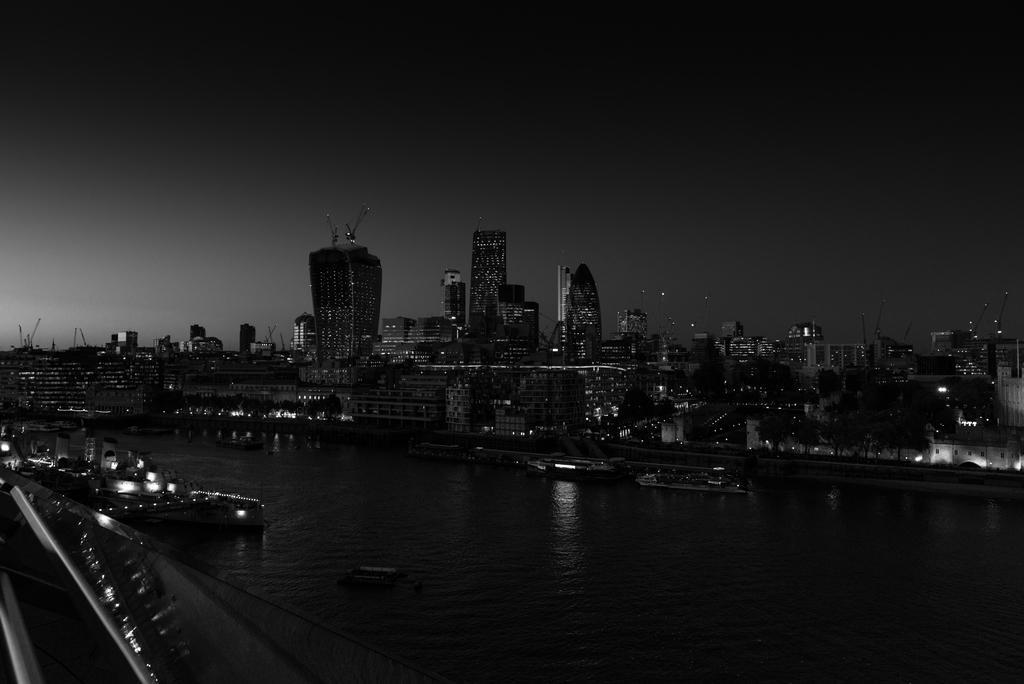Describe this image in one or two sentences. In this image, on the right side, we can see some trees, buildings. On the left side, we can see a boat which is drowning on the water. In the middle of the image, we can see a water in a lake, for boats. In the background, we can see some buildings. At the top, we can see a sky. 